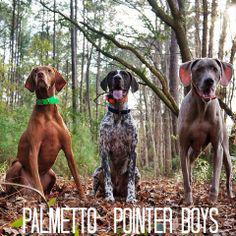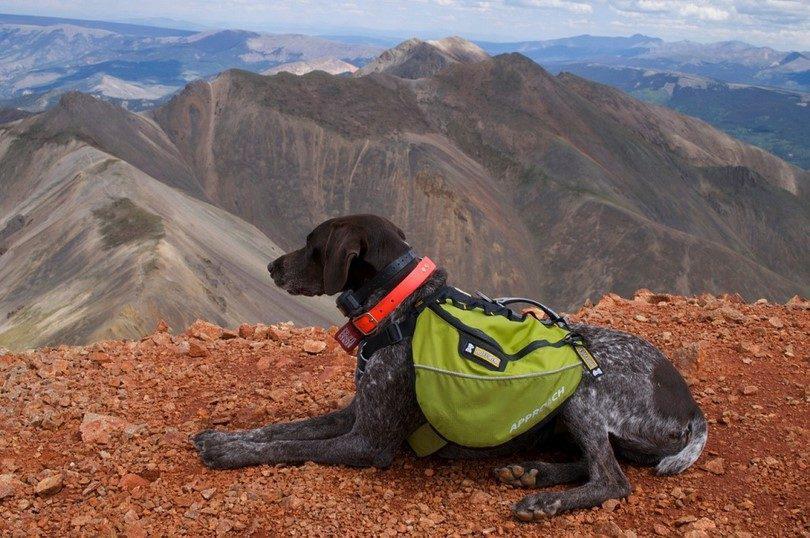The first image is the image on the left, the second image is the image on the right. Assess this claim about the two images: "In one image, exactly four dogs are at an outdoor location with one or more people.". Correct or not? Answer yes or no. No. The first image is the image on the left, the second image is the image on the right. Assess this claim about the two images: "At least some of the dogs are on a leash.". Correct or not? Answer yes or no. No. 